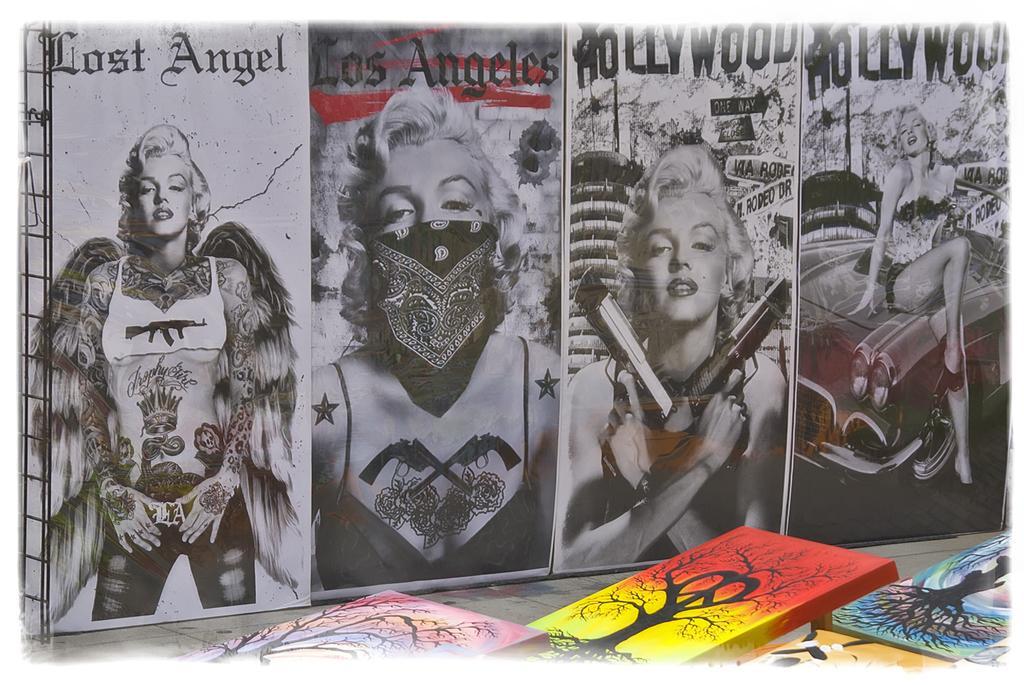How would you summarize this image in a sentence or two? In the image in the center, we can see boxes. In the background there is a poster. On the poster, we can see few people and something written on it. 